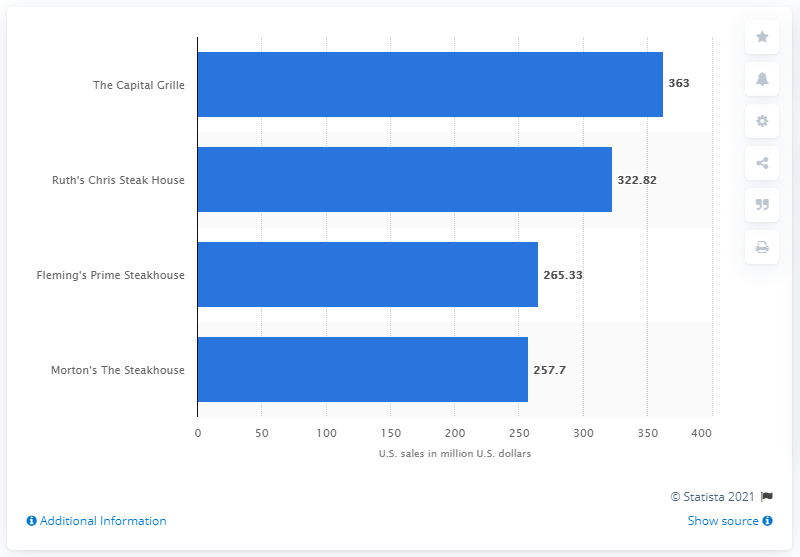Indicate a few pertinent items in this graphic. Ruth's Chris Steak House reported sales of 322.82 million dollars in the United States in 2013. Ruth's Chris Steak House is a high-end restaurant chain that operates in the United States. 